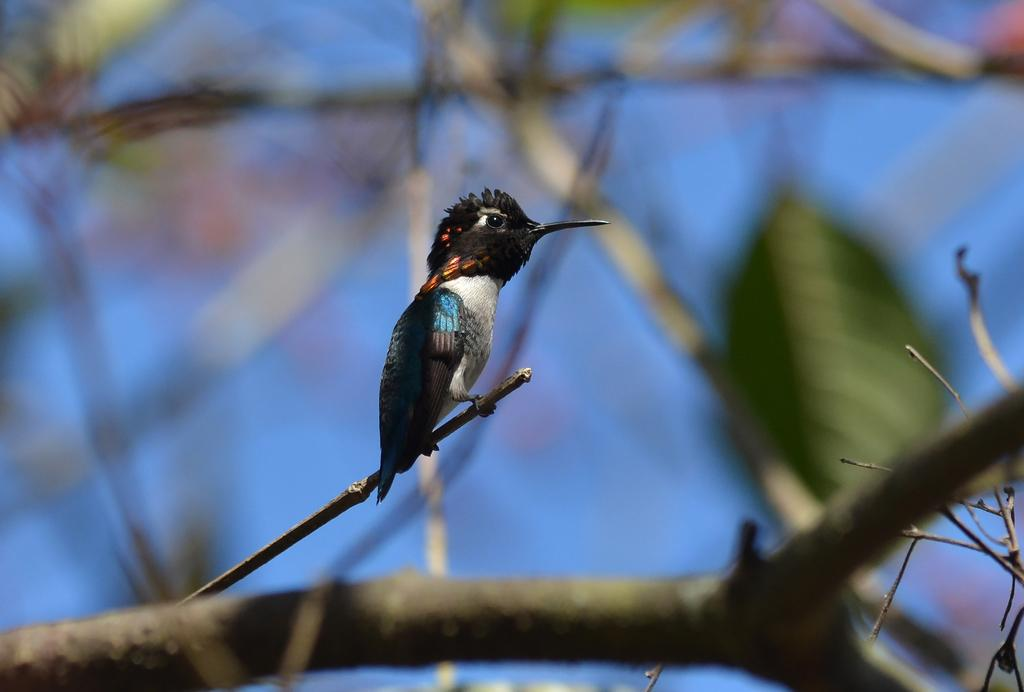What type of animal can be seen in the image? There is a bird in the image. Where is the bird located in the image? The bird is on a stem in the image. What is the bird perched on? The bird is perched on a stem that is part of a tree branch, which can be seen at the bottom of the image. What type of vegetation is present in the image? Leaves are present in the image. What type of committee is responsible for the bird's welfare in the image? There is no mention of a committee or any organization responsible for the bird's welfare in the image. 